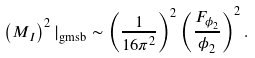<formula> <loc_0><loc_0><loc_500><loc_500>\left ( M _ { I } \right ) ^ { 2 } | _ { \text {gmsb} } \sim \left ( \frac { 1 } { 1 6 \pi ^ { 2 } } \right ) ^ { 2 } \left ( \frac { F _ { \phi _ { 2 } } } { \phi _ { 2 } } \right ) ^ { 2 } .</formula> 